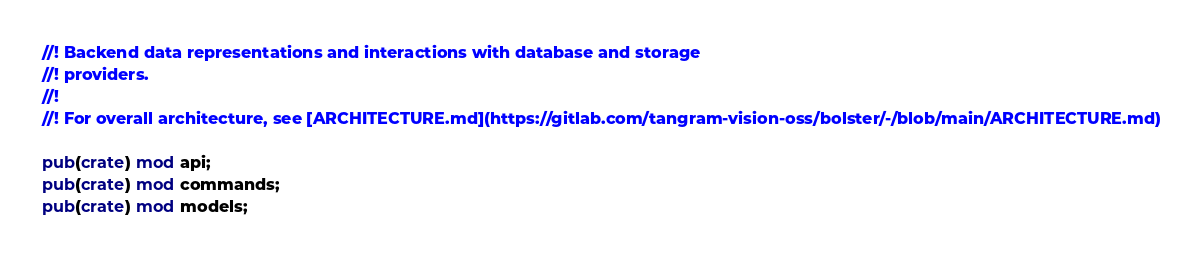Convert code to text. <code><loc_0><loc_0><loc_500><loc_500><_Rust_>//! Backend data representations and interactions with database and storage
//! providers.
//!
//! For overall architecture, see [ARCHITECTURE.md](https://gitlab.com/tangram-vision-oss/bolster/-/blob/main/ARCHITECTURE.md)

pub(crate) mod api;
pub(crate) mod commands;
pub(crate) mod models;
</code> 